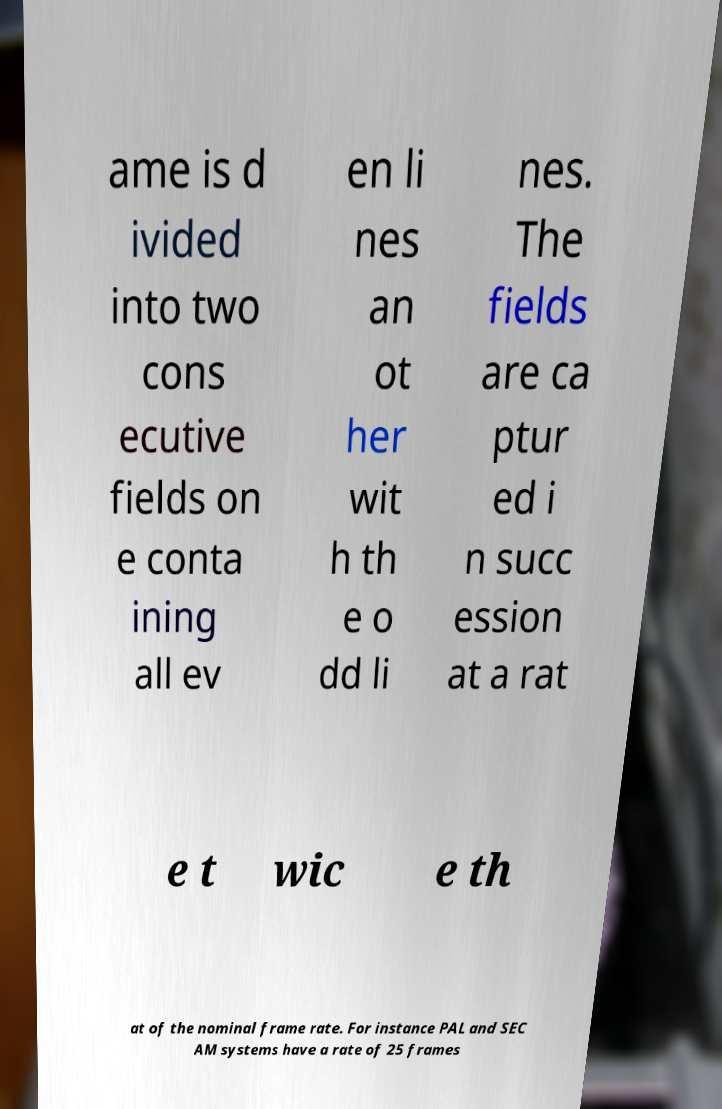What messages or text are displayed in this image? I need them in a readable, typed format. ame is d ivided into two cons ecutive fields on e conta ining all ev en li nes an ot her wit h th e o dd li nes. The fields are ca ptur ed i n succ ession at a rat e t wic e th at of the nominal frame rate. For instance PAL and SEC AM systems have a rate of 25 frames 